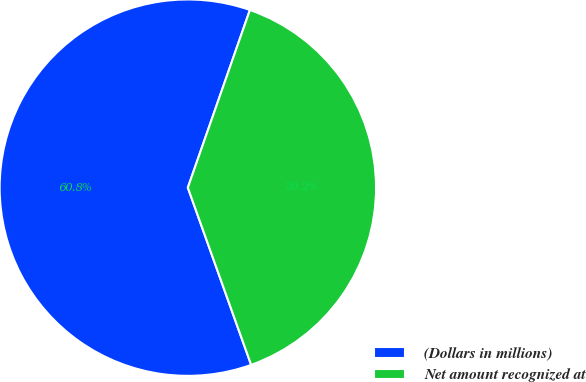Convert chart. <chart><loc_0><loc_0><loc_500><loc_500><pie_chart><fcel>(Dollars in millions)<fcel>Net amount recognized at<nl><fcel>60.81%<fcel>39.19%<nl></chart> 